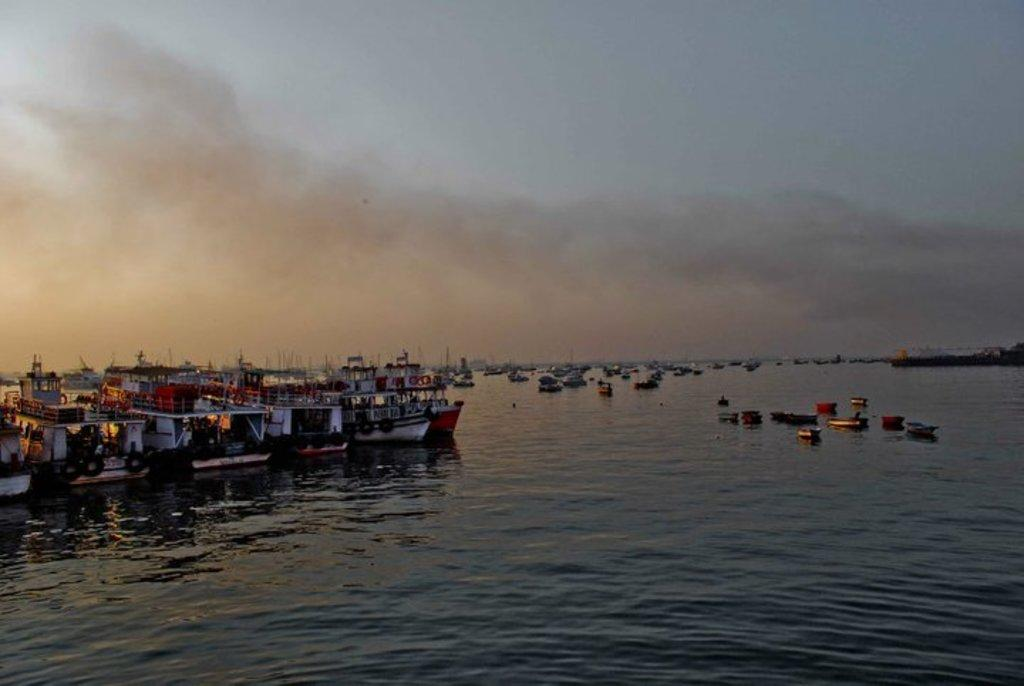What type of vehicles are in the image? There are boats in the image. Where are the boats located? The boats are on water. What part of the natural environment is visible in the image? The sky is visible in the image. How would you describe the weather based on the sky in the image? The sky is cloudy in the image. What type of range can be seen in the image? There is no range present in the image; it features boats on water with a cloudy sky. How many quarters are visible in the image? There are no quarters present in the image. 